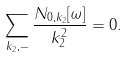Convert formula to latex. <formula><loc_0><loc_0><loc_500><loc_500>\sum _ { k _ { 2 } , - } \frac { N _ { 0 , k _ { 2 } } [ \omega ] } { k _ { 2 } ^ { 2 } } = 0 .</formula> 